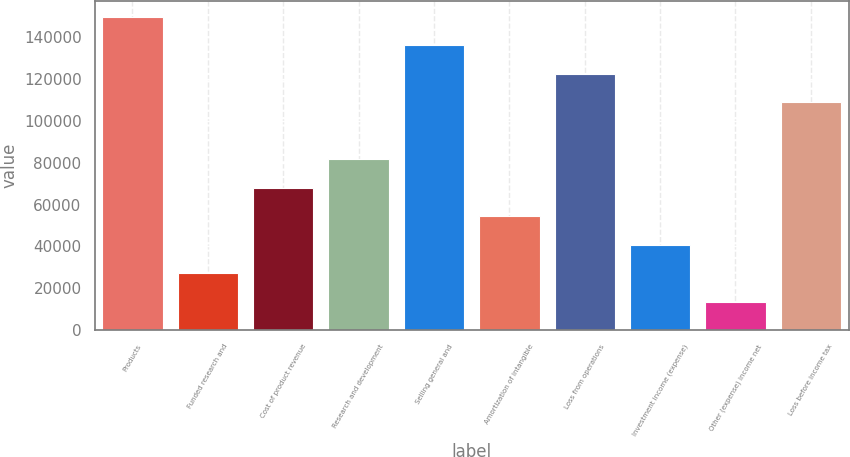Convert chart to OTSL. <chart><loc_0><loc_0><loc_500><loc_500><bar_chart><fcel>Products<fcel>Funded research and<fcel>Cost of product revenue<fcel>Research and development<fcel>Selling general and<fcel>Amortization of intangible<fcel>Loss from operations<fcel>Investment income (expense)<fcel>Other (expense) income net<fcel>Loss before income tax<nl><fcel>149801<fcel>27237.4<fcel>68092<fcel>81710.2<fcel>136183<fcel>54473.8<fcel>122565<fcel>40855.6<fcel>13619.2<fcel>108947<nl></chart> 